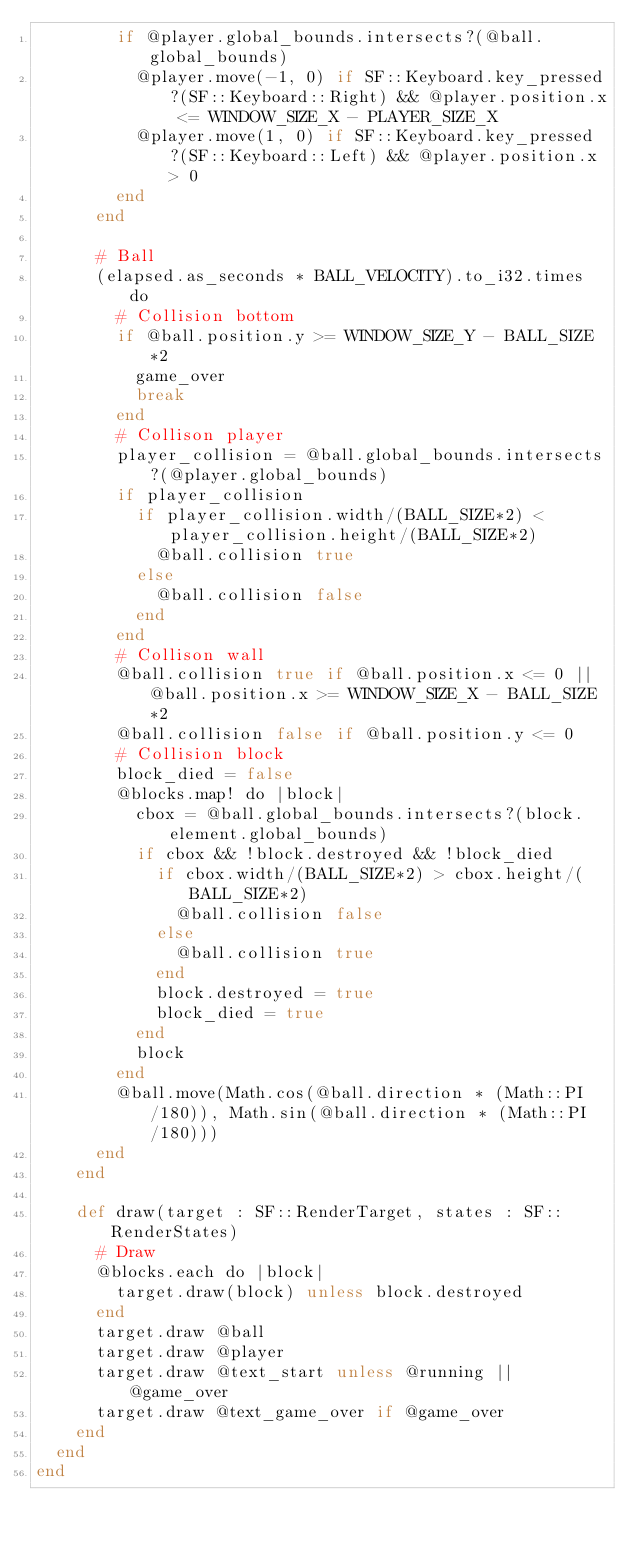<code> <loc_0><loc_0><loc_500><loc_500><_Crystal_>        if @player.global_bounds.intersects?(@ball.global_bounds)
          @player.move(-1, 0) if SF::Keyboard.key_pressed?(SF::Keyboard::Right) && @player.position.x <= WINDOW_SIZE_X - PLAYER_SIZE_X
          @player.move(1, 0) if SF::Keyboard.key_pressed?(SF::Keyboard::Left) && @player.position.x > 0
        end
      end

      # Ball
      (elapsed.as_seconds * BALL_VELOCITY).to_i32.times do
        # Collision bottom
        if @ball.position.y >= WINDOW_SIZE_Y - BALL_SIZE*2
          game_over
          break
        end
        # Collison player
        player_collision = @ball.global_bounds.intersects?(@player.global_bounds)
        if player_collision
          if player_collision.width/(BALL_SIZE*2) < player_collision.height/(BALL_SIZE*2)
            @ball.collision true
          else
            @ball.collision false
          end
        end
        # Collison wall
        @ball.collision true if @ball.position.x <= 0 || @ball.position.x >= WINDOW_SIZE_X - BALL_SIZE*2
        @ball.collision false if @ball.position.y <= 0
        # Collision block
        block_died = false
        @blocks.map! do |block|
          cbox = @ball.global_bounds.intersects?(block.element.global_bounds)
          if cbox && !block.destroyed && !block_died
            if cbox.width/(BALL_SIZE*2) > cbox.height/(BALL_SIZE*2)
              @ball.collision false
            else
              @ball.collision true
            end
            block.destroyed = true
            block_died = true
          end
          block
        end
        @ball.move(Math.cos(@ball.direction * (Math::PI/180)), Math.sin(@ball.direction * (Math::PI/180)))
      end
    end

    def draw(target : SF::RenderTarget, states : SF::RenderStates)
      # Draw
      @blocks.each do |block|
        target.draw(block) unless block.destroyed
      end
      target.draw @ball
      target.draw @player
      target.draw @text_start unless @running || @game_over
      target.draw @text_game_over if @game_over
    end
  end
end
</code> 